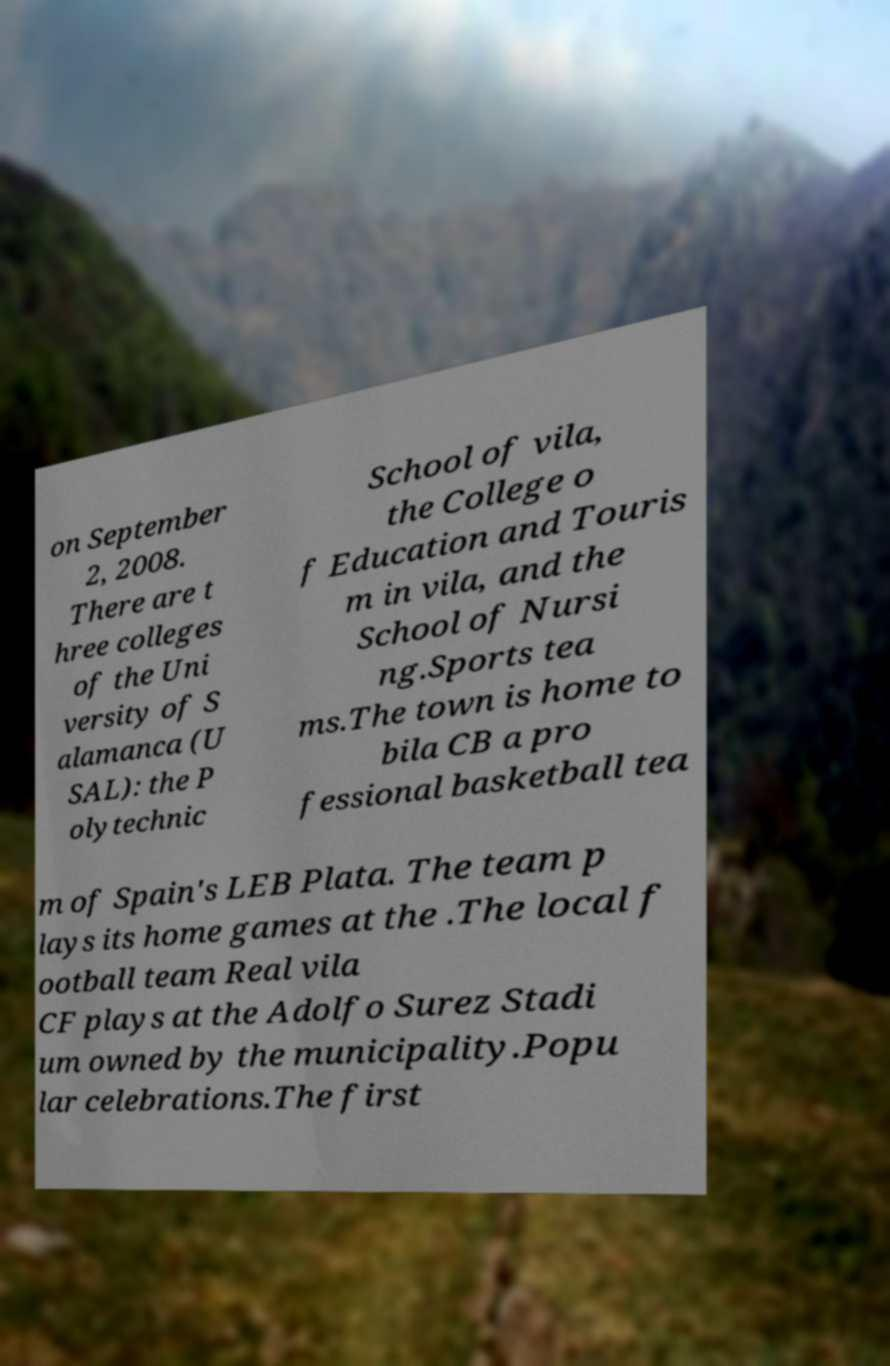Please read and relay the text visible in this image. What does it say? on September 2, 2008. There are t hree colleges of the Uni versity of S alamanca (U SAL): the P olytechnic School of vila, the College o f Education and Touris m in vila, and the School of Nursi ng.Sports tea ms.The town is home to bila CB a pro fessional basketball tea m of Spain's LEB Plata. The team p lays its home games at the .The local f ootball team Real vila CF plays at the Adolfo Surez Stadi um owned by the municipality.Popu lar celebrations.The first 